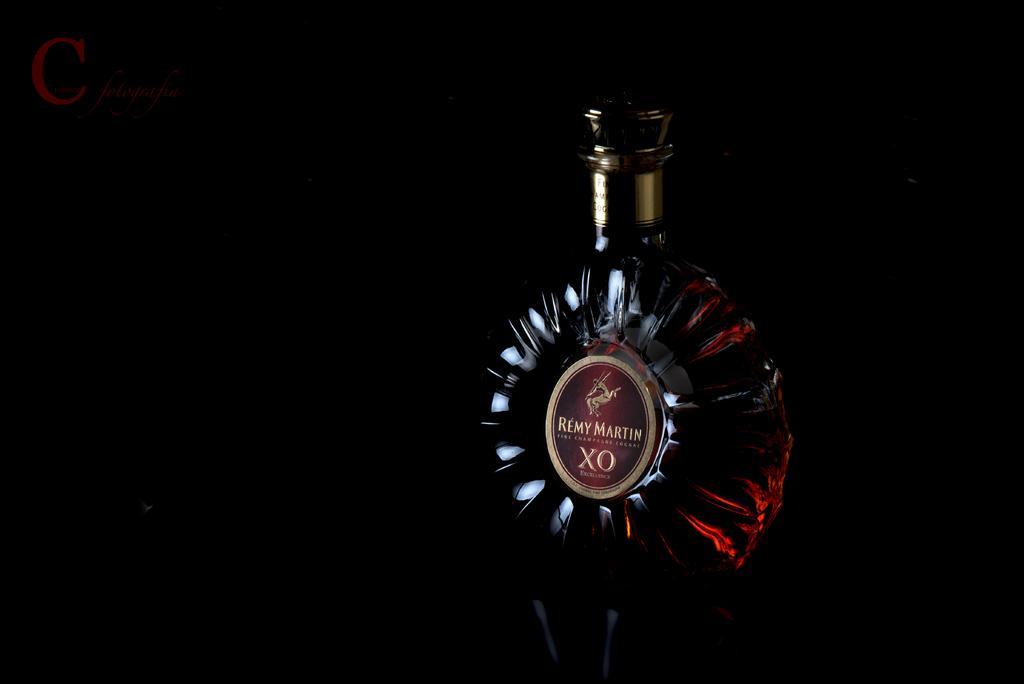Describe this image in one or two sentences. This image is clicked in dark room. In this image, there is a alcohol bottle. On which a sticker is pasted. On the sticker it is written as 'REMY MARTIN'. 